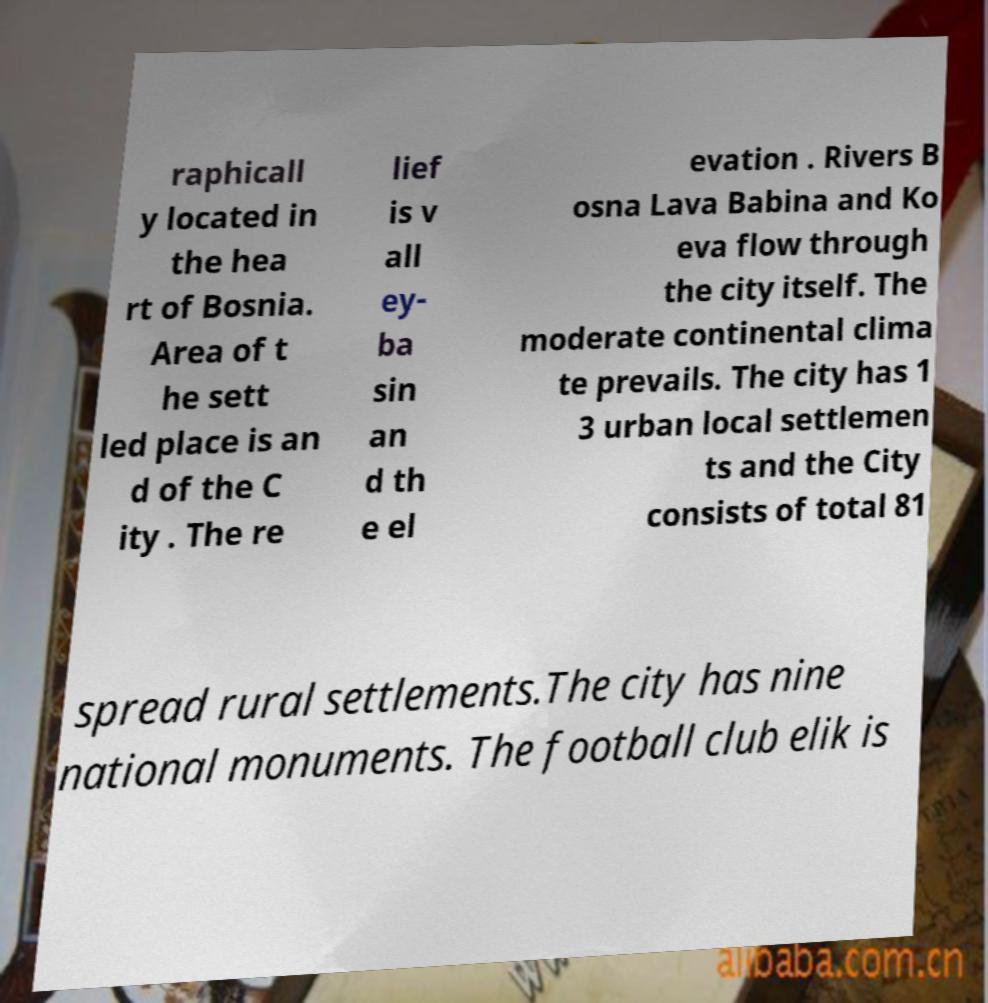There's text embedded in this image that I need extracted. Can you transcribe it verbatim? raphicall y located in the hea rt of Bosnia. Area of t he sett led place is an d of the C ity . The re lief is v all ey- ba sin an d th e el evation . Rivers B osna Lava Babina and Ko eva flow through the city itself. The moderate continental clima te prevails. The city has 1 3 urban local settlemen ts and the City consists of total 81 spread rural settlements.The city has nine national monuments. The football club elik is 